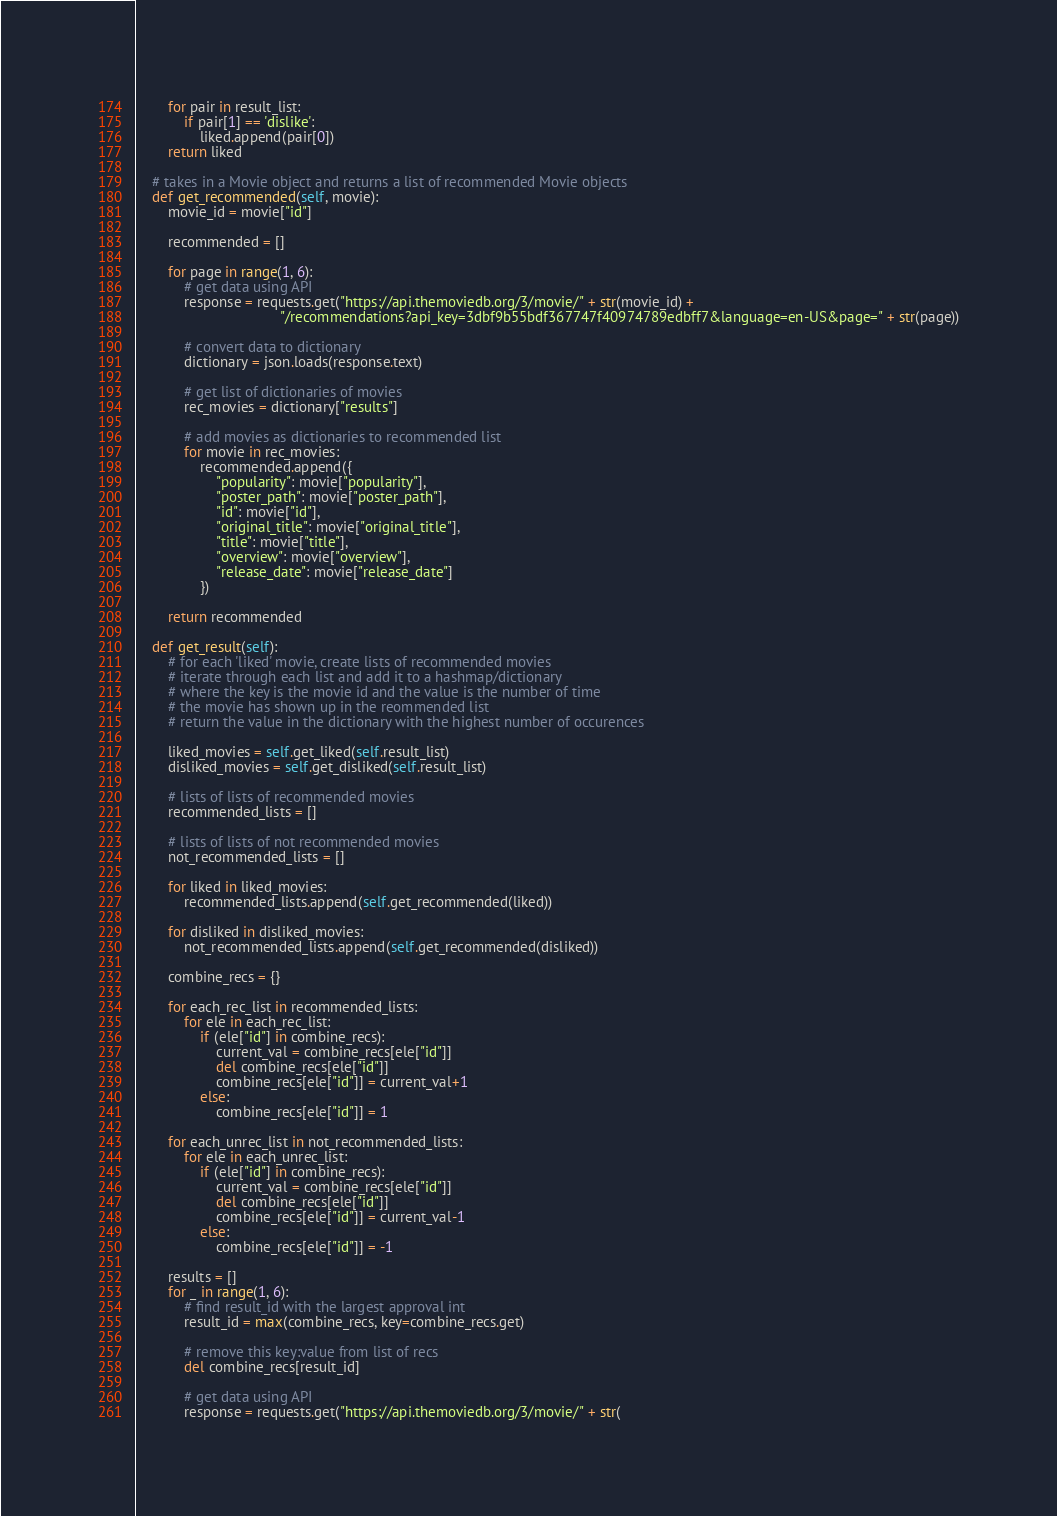<code> <loc_0><loc_0><loc_500><loc_500><_Python_>        for pair in result_list:
            if pair[1] == 'dislike':
                liked.append(pair[0])
        return liked

    # takes in a Movie object and returns a list of recommended Movie objects
    def get_recommended(self, movie):
        movie_id = movie["id"]

        recommended = []

        for page in range(1, 6):
            # get data using API
            response = requests.get("https://api.themoviedb.org/3/movie/" + str(movie_id) +
                                    "/recommendations?api_key=3dbf9b55bdf367747f40974789edbff7&language=en-US&page=" + str(page))

            # convert data to dictionary
            dictionary = json.loads(response.text)

            # get list of dictionaries of movies
            rec_movies = dictionary["results"]

            # add movies as dictionaries to recommended list
            for movie in rec_movies:
                recommended.append({
                    "popularity": movie["popularity"],
                    "poster_path": movie["poster_path"],
                    "id": movie["id"],
                    "original_title": movie["original_title"],
                    "title": movie["title"],
                    "overview": movie["overview"],
                    "release_date": movie["release_date"]
                })

        return recommended

    def get_result(self):
        # for each 'liked' movie, create lists of recommended movies
        # iterate through each list and add it to a hashmap/dictionary
        # where the key is the movie id and the value is the number of time
        # the movie has shown up in the reommended list
        # return the value in the dictionary with the highest number of occurences

        liked_movies = self.get_liked(self.result_list)
        disliked_movies = self.get_disliked(self.result_list)

        # lists of lists of recommended movies
        recommended_lists = []

        # lists of lists of not recommended movies
        not_recommended_lists = []

        for liked in liked_movies:
            recommended_lists.append(self.get_recommended(liked))

        for disliked in disliked_movies:
            not_recommended_lists.append(self.get_recommended(disliked))

        combine_recs = {}

        for each_rec_list in recommended_lists:
            for ele in each_rec_list:
                if (ele["id"] in combine_recs):
                    current_val = combine_recs[ele["id"]]
                    del combine_recs[ele["id"]]
                    combine_recs[ele["id"]] = current_val+1
                else:
                    combine_recs[ele["id"]] = 1

        for each_unrec_list in not_recommended_lists:
            for ele in each_unrec_list:
                if (ele["id"] in combine_recs):
                    current_val = combine_recs[ele["id"]]
                    del combine_recs[ele["id"]]
                    combine_recs[ele["id"]] = current_val-1
                else:
                    combine_recs[ele["id"]] = -1

        results = []
        for _ in range(1, 6):
            # find result_id with the largest approval int
            result_id = max(combine_recs, key=combine_recs.get)

            # remove this key:value from list of recs
            del combine_recs[result_id]

            # get data using API
            response = requests.get("https://api.themoviedb.org/3/movie/" + str(</code> 